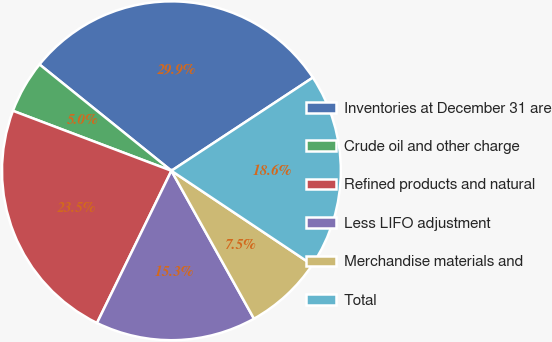<chart> <loc_0><loc_0><loc_500><loc_500><pie_chart><fcel>Inventories at December 31 are<fcel>Crude oil and other charge<fcel>Refined products and natural<fcel>Less LIFO adjustment<fcel>Merchandise materials and<fcel>Total<nl><fcel>29.93%<fcel>5.04%<fcel>23.52%<fcel>15.34%<fcel>7.53%<fcel>18.64%<nl></chart> 